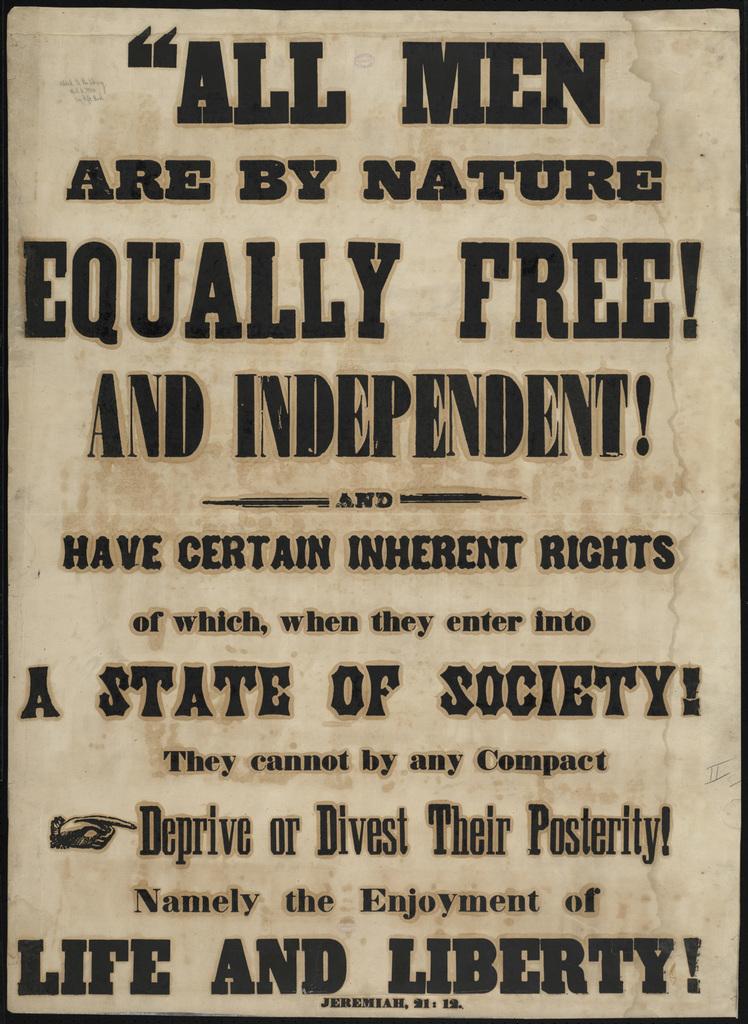What are all men by nature?
Your response must be concise. Equally free. What type of rights do we have?
Offer a very short reply. Inherent. 